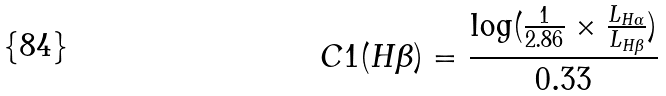<formula> <loc_0><loc_0><loc_500><loc_500>C 1 ( H \beta ) = \frac { \log ( \frac { 1 } { 2 . 8 6 } \times \frac { L _ { H \alpha } } { L _ { H \beta } } ) } { 0 . 3 3 }</formula> 